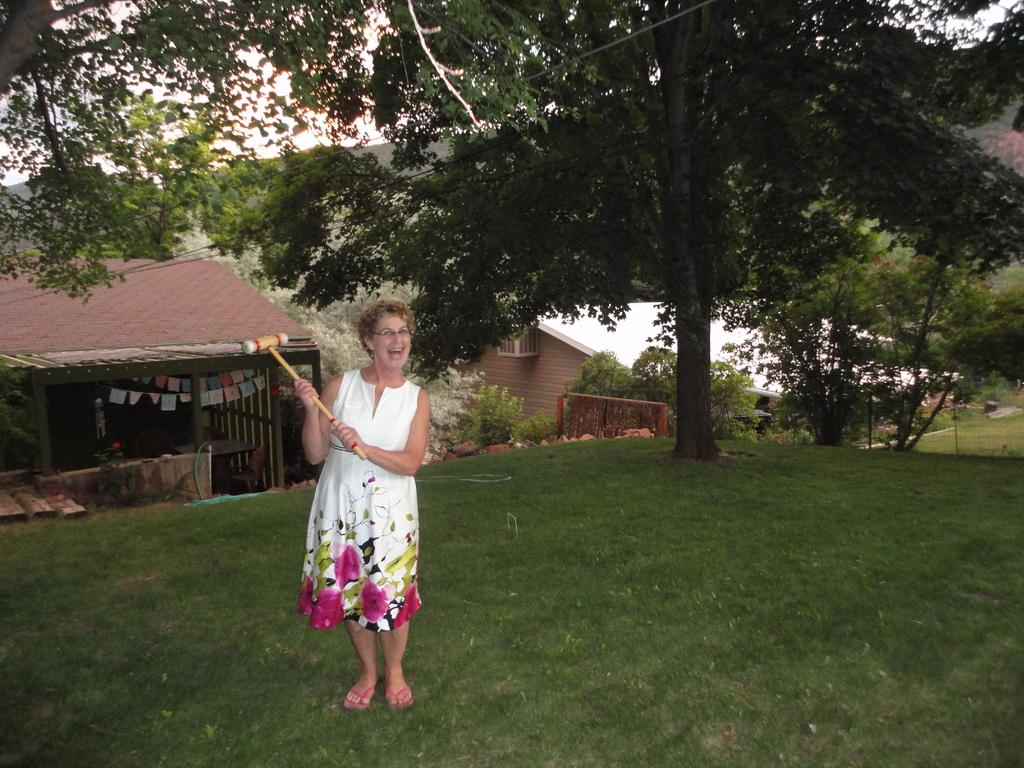What is the woman in the image holding? The woman is holding a hammer. What is the woman's expression in the image? The woman is smiling. What is the woman's position in relation to the ground? The woman is standing on the ground. What can be seen in the background of the image? There are trees, houses, and the sky visible in the background of the image. What type of clouds can be seen in the image? There are no clouds mentioned or visible in the image. Is the woman holding an umbrella in the image? No, the woman is holding a hammer, not an umbrella. 